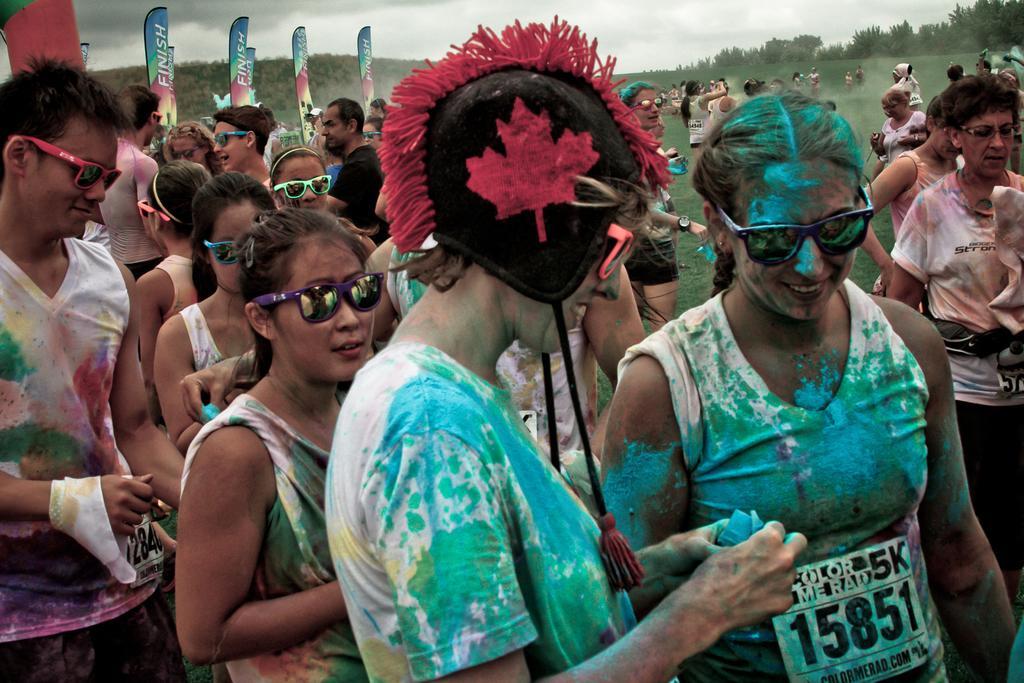Describe this image in one or two sentences. In the center of the image we can see people standing. They are all dressed in costumes. In the background there are flags, trees and sky. 